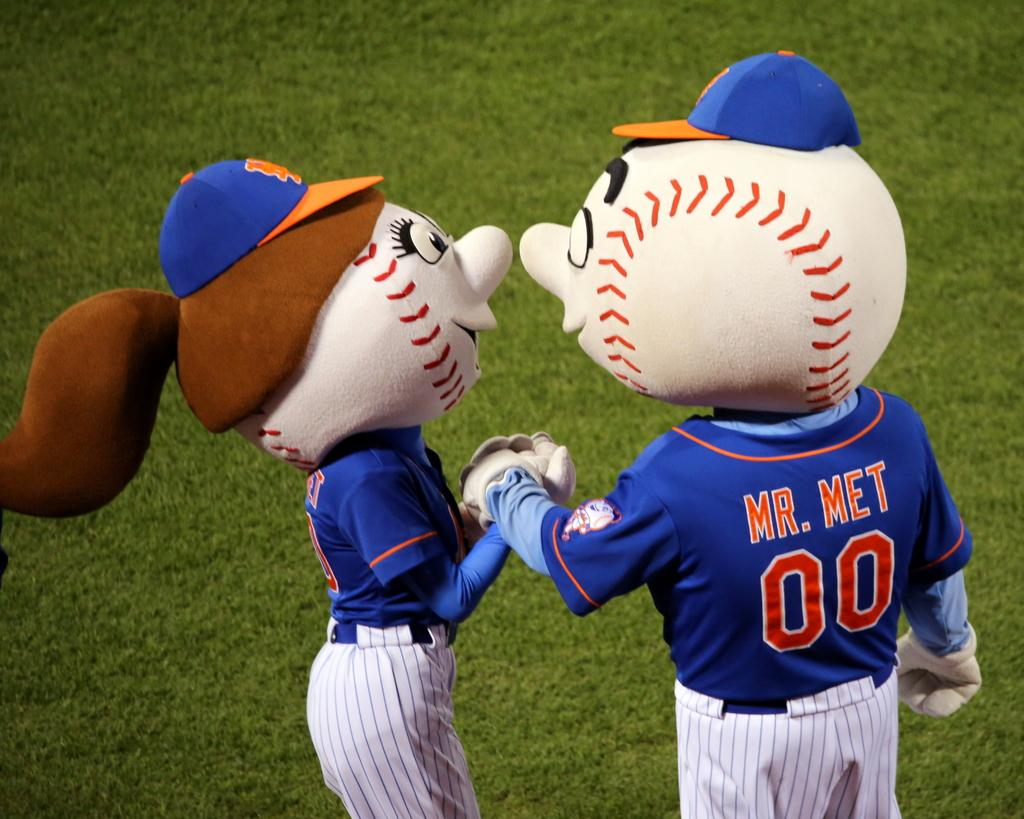<image>
Share a concise interpretation of the image provided. A girl and boy mascot for the Mets baseball team. 